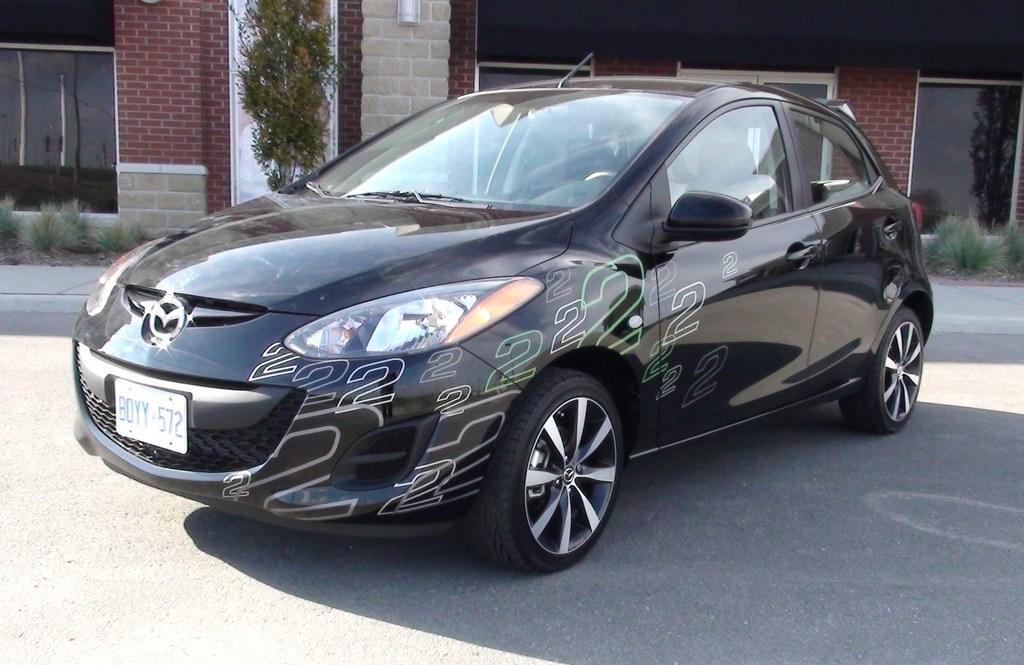In one or two sentences, can you explain what this image depicts? This picture shows a black car and we see buildings and a tree and few plants and glass Windows. 